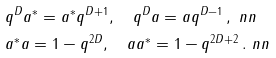Convert formula to latex. <formula><loc_0><loc_0><loc_500><loc_500>& q ^ { D } a ^ { * } = a ^ { * } q ^ { D + 1 } , \quad q ^ { D } a = a q ^ { D - 1 } \, , \ n n \\ & a ^ { * } a = 1 - q ^ { 2 D } , \quad a a ^ { * } = 1 - q ^ { 2 D + 2 } \, . \ n n</formula> 